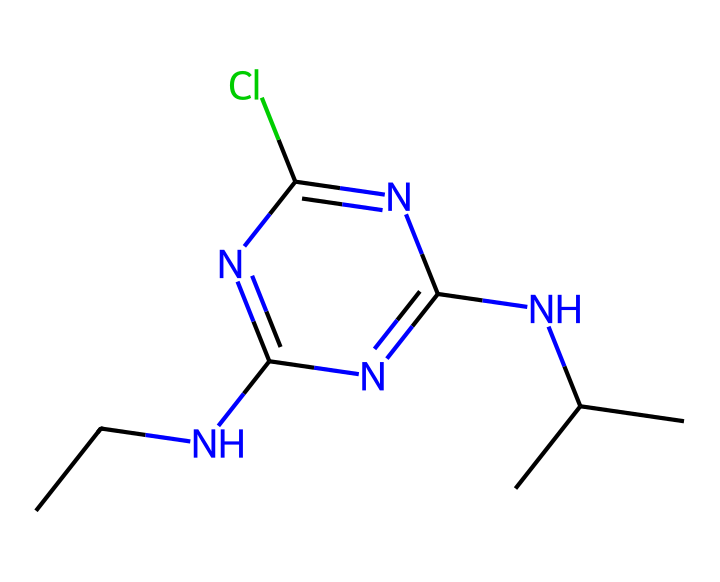What is the molecular formula of atrazine? By analyzing the SMILES representation, we can count the various atoms present: there are two carbon (C) atoms from 'CC', four nitrogen (N) atoms from 'N' and 'n', and one chlorine (Cl) from 'Cl'. Thus, the total counts yield a molecular formula of C8H14ClN5.
Answer: C8H14ClN5 How many nitrogen atoms are in atrazine? The SMILES shows four occurrences of 'N' and 'n', which represent nitrogen atoms. Hence, there are four nitrogen atoms in the structure.
Answer: four What functional groups can be identified in atrazine? From the SMILES, we can identify a primary amine (from 'CCN'), an aromatic ring (denoted by 'n' within the cyclic structure), and a chloro group (from 'Cl'). These represent the primary functional groups present in atrazine.
Answer: primary amine, aromatic, chloro What is the significance of the chlorine atom in atrazine? The chlorine atom is known to enhance the herbicidal properties of atrazine, increasing its persistence in the environment. This structural component significantly contributes to its activity as a selective herbicide.
Answer: herbicidal properties How does the presence of multiple nitrogen atoms affect atrazine’s solubility? Multiple nitrogen atoms in atrazine create sites for hydrogen bonding with water. Increased polar interactions through these nitrogen sites allow atrazine to be more soluble in water compared to non-nitrogenated herbicides.
Answer: increases solubility What type of herbicide is atrazine classified as? Based on its chemical structure and mechanism of action, atrazine is classified as a selective herbicide, specifically effective against broadleaf weeds while being less harmful to certain grasses.
Answer: selective herbicide 